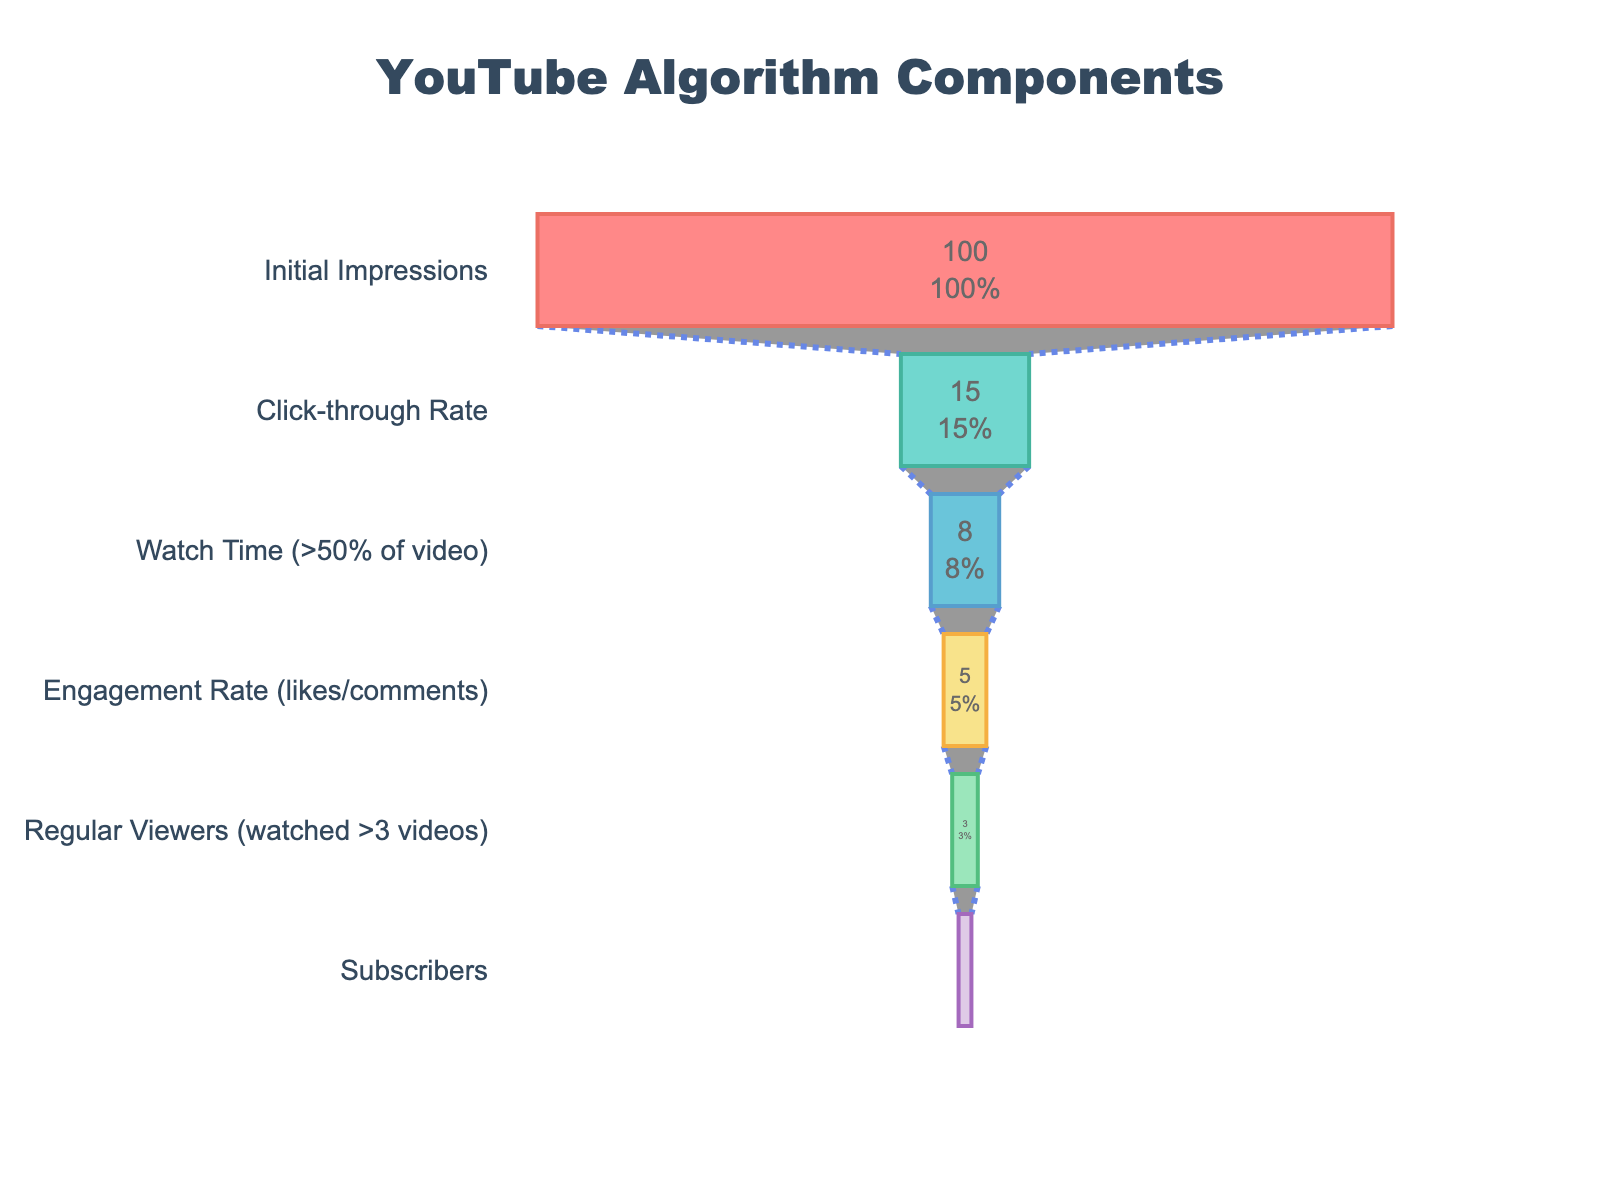what is the title of the chart? The title is displayed prominently at the top of the chart. It reads "YouTube Algorithm Components" as stated in the layout section of the code.
Answer: YouTube Algorithm Components How many categories are included in the funnel chart? By examining the list of steps, we can see the data includes the following categories: Initial Impressions, Click-through Rate, Watch Time (>50% of video), Engagement Rate (likes/comments), Regular Viewers (watched >3 videos), and Subscribers. So, there are 6 categories.
Answer: 6 What is the percentage of views that convert into subscribers? By looking at the "Subscribers" category in the chart, we can see that 1.5% of the views convert into subscribers.
Answer: 1.5% What percentage of users engaged (likes/comments) with the videos? The Engagement Rate (likes/comments) section of the funnel chart shows that 5% of users engaged with the videos.
Answer: 5% What is the difference between the percentage of users who watched more than 50% of the video and those who became regular viewers? To find the difference, we look at "Watch Time (>50% of video)" which is 8% and "Regular Viewers (watched >3 videos)" which is 3%. The difference is calculated as 8% - 3% = 5%.
Answer: 5% How does the click-through rate compare to the engagement rate? The click-through rate is 15% and the engagement rate is 5%. Therefore, the click-through rate is higher than the engagement rate.
Answer: Click-through rate is higher What proportion of initial impressions converts into watch time (>50% of video)? The proportion is calculated by dividing the percentage of Watch Time (>50% of video), which is 8%, by the total initial impressions, 100%. Hence, the proportion is 8/100 = 0.08 or 8%.
Answer: 8% Which component has the lowest percentage in the funnel? By examining all components, we can see that "Subscribers" has the lowest percentage at 1.5%.
Answer: Subscribers What percentage of initial impressions result in regular viewers? "Regular Viewers (watched >3 videos)" shows 3% in the funnel chart. This means 3% of initial impressions result in regular viewers.
Answer: 3% Which step loses the most significant percentage of users in the funnel? By comparing the percentage drop between each step, the largest difference is between "Initial Impressions" at 100% and "Click-through Rate" at 15%, resulting in a drop of 100% - 15% = 85%.
Answer: Initial Impressions to Click-through Rate 